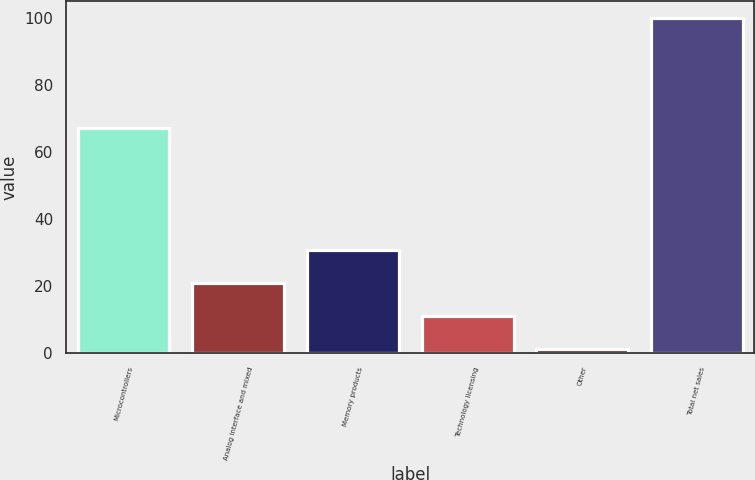<chart> <loc_0><loc_0><loc_500><loc_500><bar_chart><fcel>Microcontrollers<fcel>Analog interface and mixed<fcel>Memory products<fcel>Technology licensing<fcel>Other<fcel>Total net sales<nl><fcel>67.1<fcel>20.96<fcel>30.84<fcel>11.08<fcel>1.2<fcel>100<nl></chart> 